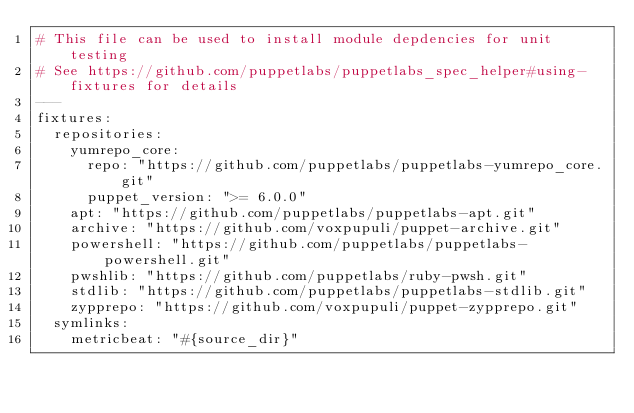<code> <loc_0><loc_0><loc_500><loc_500><_YAML_># This file can be used to install module depdencies for unit testing
# See https://github.com/puppetlabs/puppetlabs_spec_helper#using-fixtures for details
---
fixtures:
  repositories:
    yumrepo_core:
      repo: "https://github.com/puppetlabs/puppetlabs-yumrepo_core.git"
      puppet_version: ">= 6.0.0"
    apt: "https://github.com/puppetlabs/puppetlabs-apt.git"
    archive: "https://github.com/voxpupuli/puppet-archive.git"
    powershell: "https://github.com/puppetlabs/puppetlabs-powershell.git"
    pwshlib: "https://github.com/puppetlabs/ruby-pwsh.git"
    stdlib: "https://github.com/puppetlabs/puppetlabs-stdlib.git"
    zypprepo: "https://github.com/voxpupuli/puppet-zypprepo.git"
  symlinks:
    metricbeat: "#{source_dir}"
</code> 